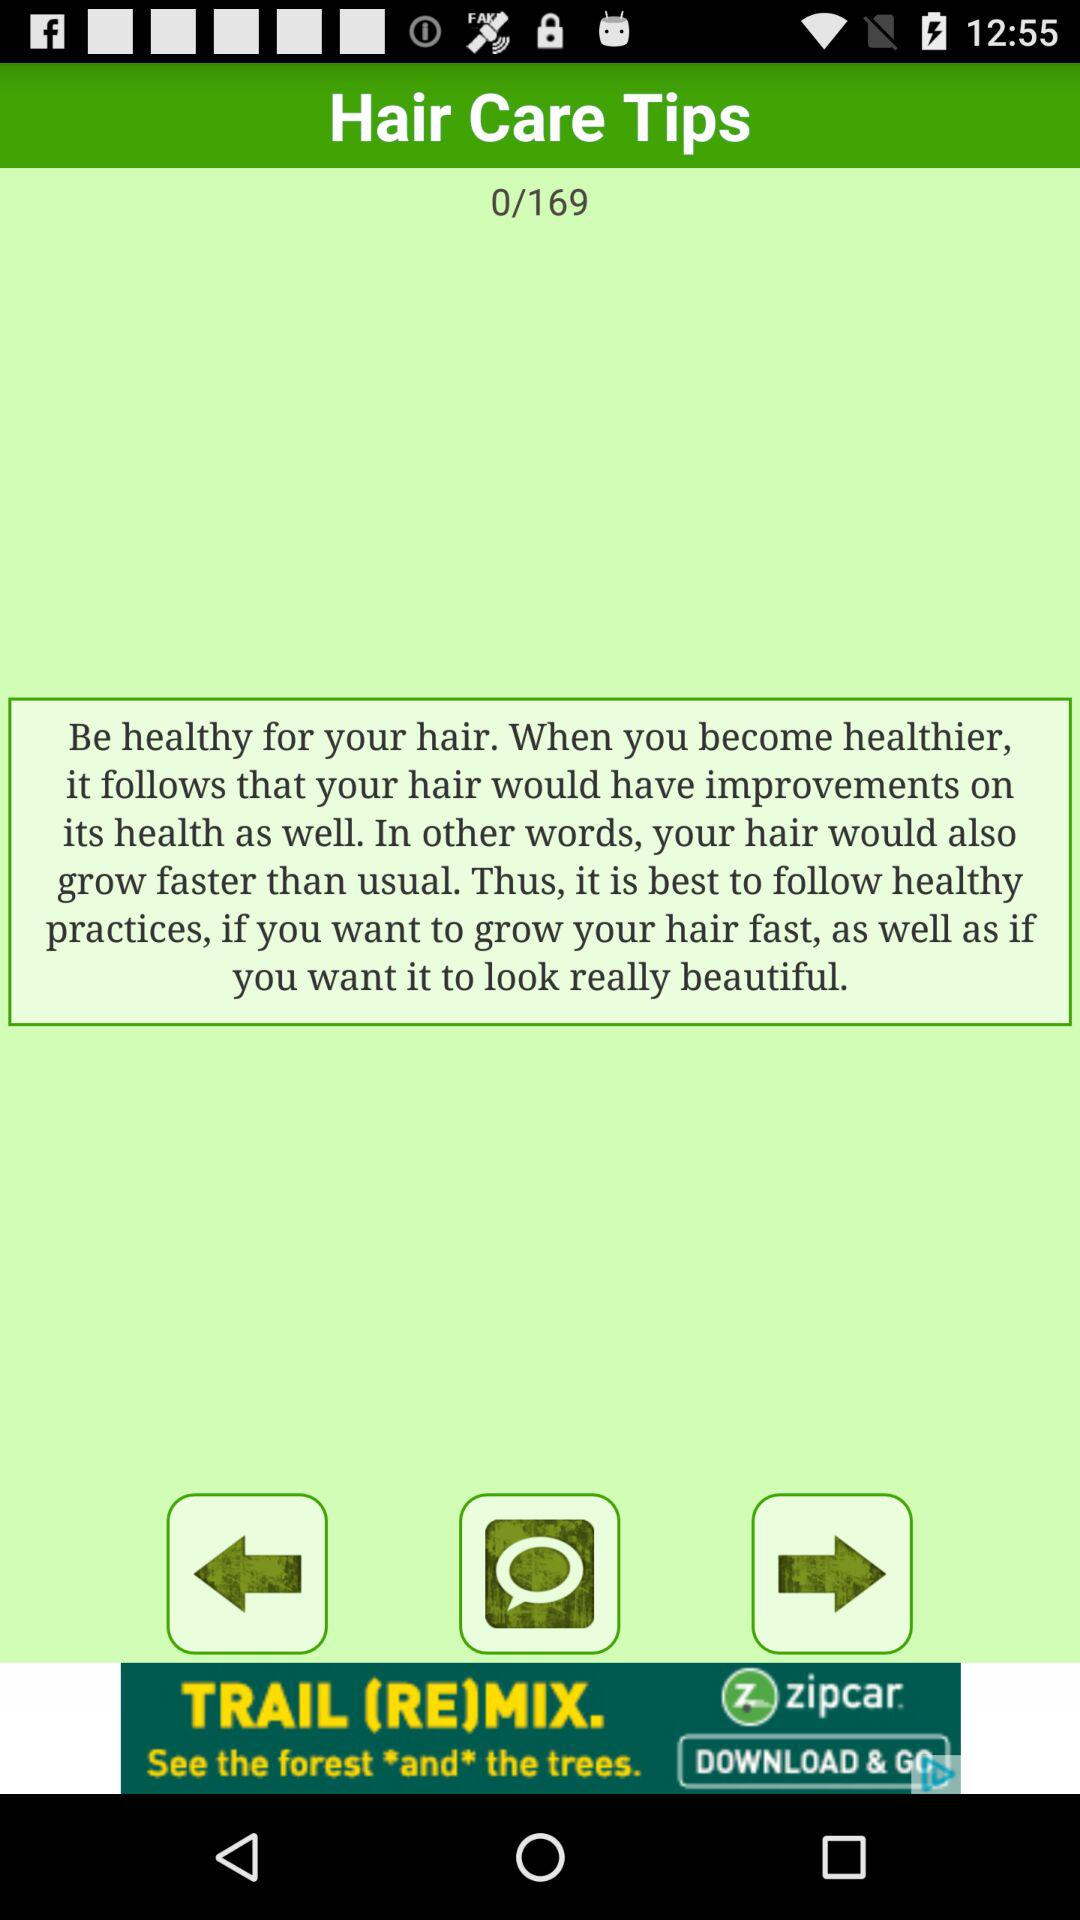What is the total number of hair care tips? The total number of hair care tips is 169. 